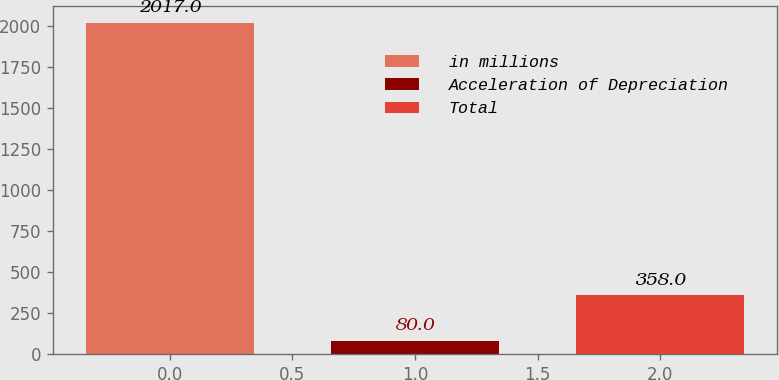<chart> <loc_0><loc_0><loc_500><loc_500><bar_chart><fcel>in millions<fcel>Acceleration of Depreciation<fcel>Total<nl><fcel>2017<fcel>80<fcel>358<nl></chart> 